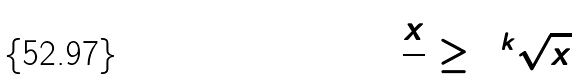Convert formula to latex. <formula><loc_0><loc_0><loc_500><loc_500>\frac { x } { 2 } \geq 2 ^ { k } \sqrt { x }</formula> 